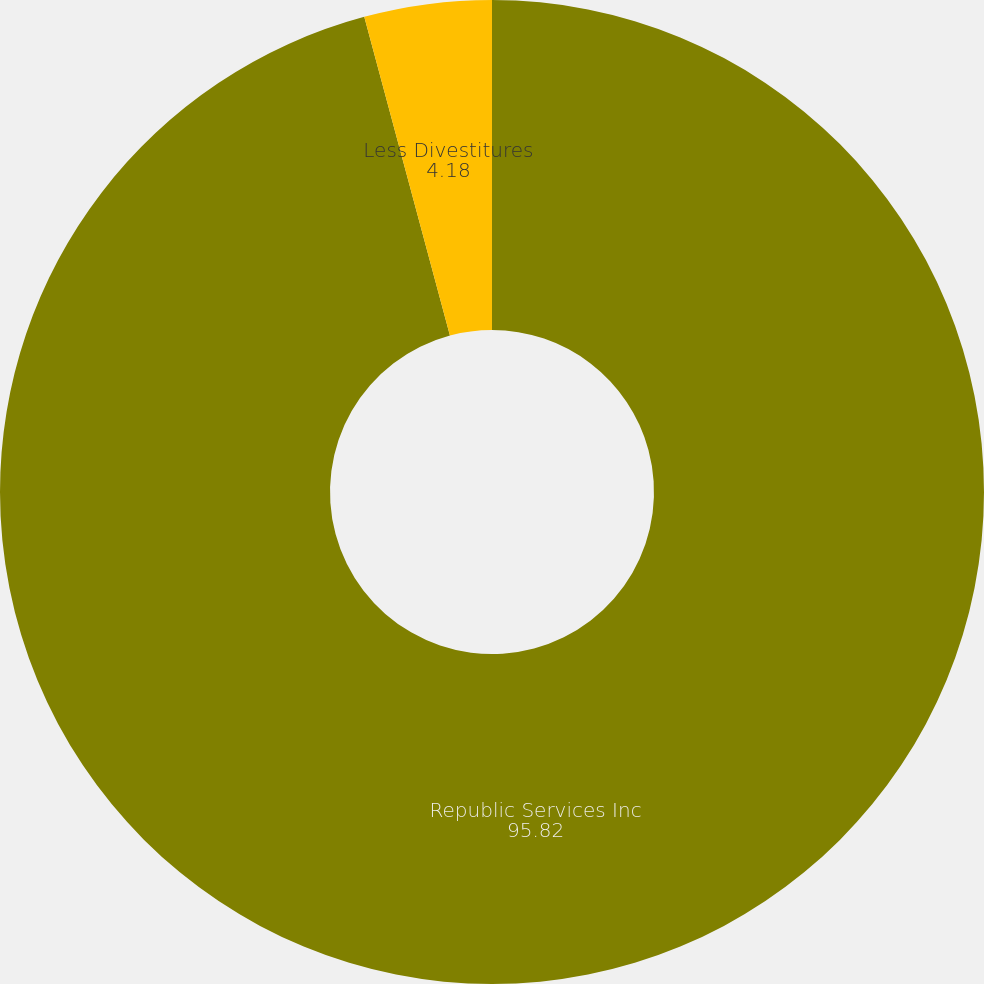<chart> <loc_0><loc_0><loc_500><loc_500><pie_chart><fcel>Republic Services Inc<fcel>Less Divestitures<nl><fcel>95.82%<fcel>4.18%<nl></chart> 